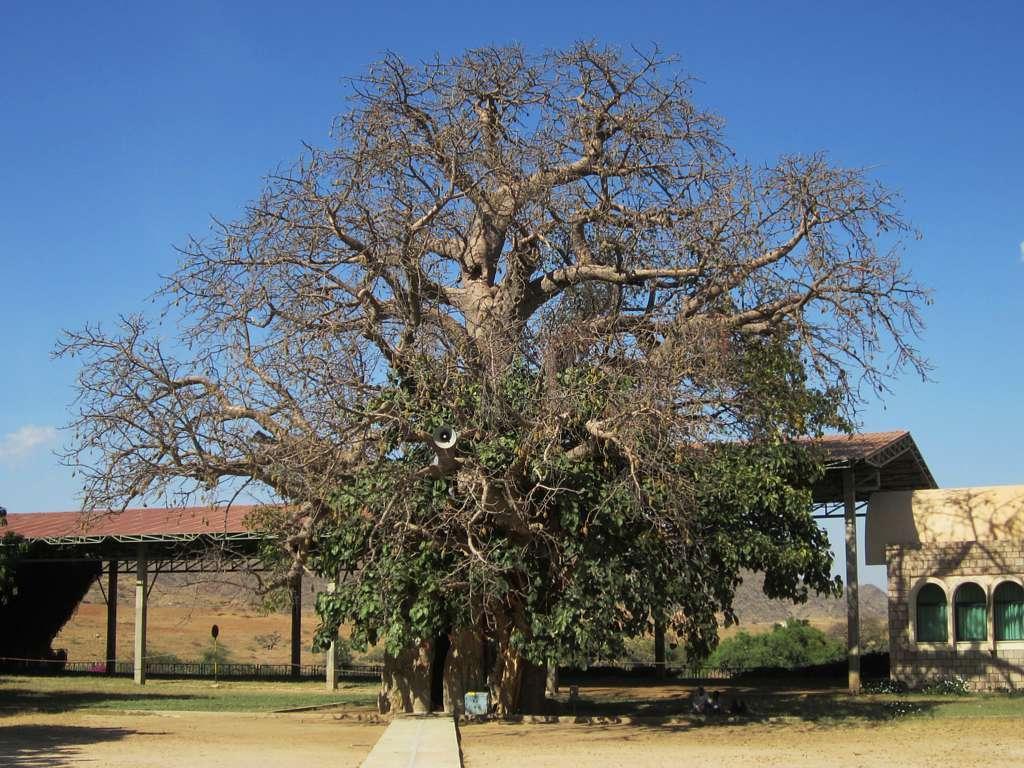Describe this image in one or two sentences. This is the picture of a place where we have a shed, house which has three windows and a tree on the floor. 